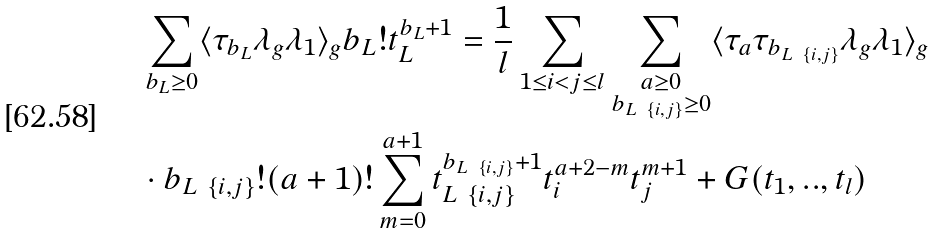Convert formula to latex. <formula><loc_0><loc_0><loc_500><loc_500>& \sum _ { b _ { L } \geq 0 } \langle \tau _ { b _ { L } } \lambda _ { g } \lambda _ { 1 } \rangle _ { g } b _ { L } ! t _ { L } ^ { b _ { L } + 1 } = \frac { 1 } { l } \sum _ { 1 \leq i < j \leq l } \sum _ { \substack { a \geq 0 \\ b _ { L \ \{ i , j \} } \geq 0 } } \langle \tau _ { a } \tau _ { b _ { L \ \{ i , j \} } } \lambda _ { g } \lambda _ { 1 } \rangle _ { g } \\ & \cdot b _ { L \ \{ i , j \} } ! ( a + 1 ) ! \sum _ { m = 0 } ^ { a + 1 } t _ { L \ \{ i , j \} } ^ { b _ { L \ \{ i , j \} } + 1 } t _ { i } ^ { a + 2 - m } t _ { j } ^ { m + 1 } + G ( t _ { 1 } , . . , t _ { l } )</formula> 